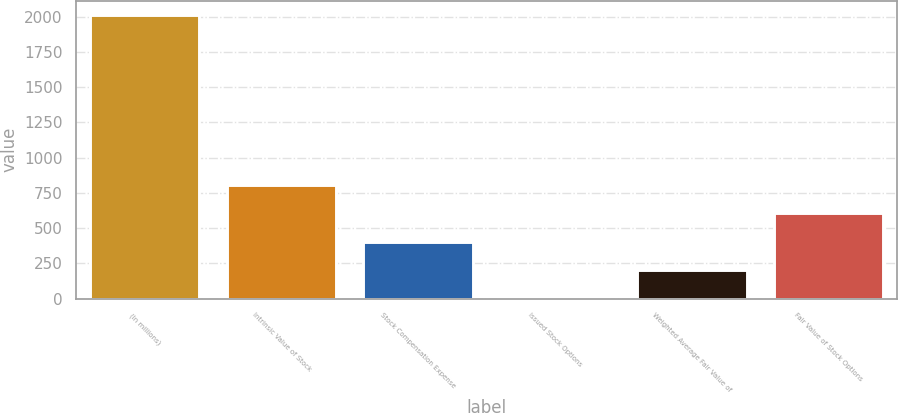<chart> <loc_0><loc_0><loc_500><loc_500><bar_chart><fcel>(In millions)<fcel>Intrinsic Value of Stock<fcel>Stock Compensation Expense<fcel>Issued Stock Options<fcel>Weighted Average Fair Value of<fcel>Fair Value of Stock Options<nl><fcel>2012<fcel>805.76<fcel>403.68<fcel>1.6<fcel>202.64<fcel>604.72<nl></chart> 